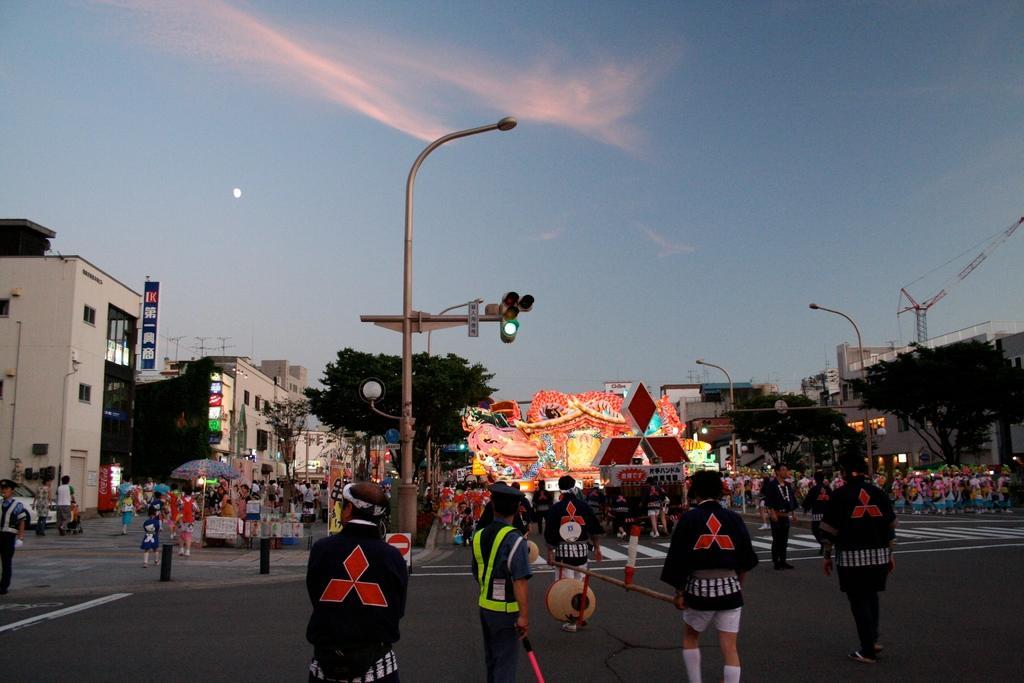In one or two sentences, can you explain what this image depicts? In the center of the image we can see the stage, logo, boards, decor, lights. In the background of the image we can see the buildings, trees, poles, lights, traffic lights, windows, crane, tent, refrigerator, vehicle and a group of people are standing. At the bottom of the image we can see the road. At the top of the image we can see the clouds are present in the sky and moon. 